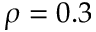<formula> <loc_0><loc_0><loc_500><loc_500>\rho = 0 . 3</formula> 